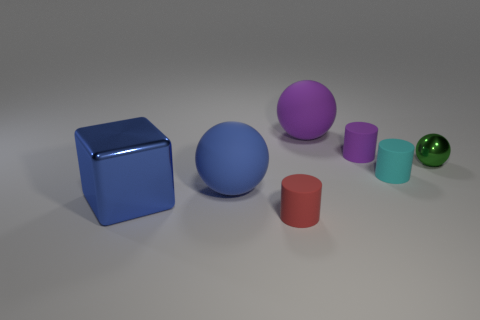Add 1 tiny cyan rubber objects. How many objects exist? 8 Subtract all cylinders. How many objects are left? 4 Add 5 large green blocks. How many large green blocks exist? 5 Subtract 0 brown spheres. How many objects are left? 7 Subtract all blue metallic objects. Subtract all big blue metallic blocks. How many objects are left? 5 Add 3 rubber things. How many rubber things are left? 8 